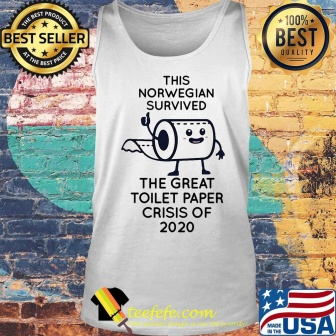Can you describe the main features of this image for me? The image showcases a white tank top, humorously designed and hung against a brick wall backdrop. The tank top features a cartoon of a roll of toilet paper, anthropomorphized with arms and legs. The toilet paper roll appears to be in a triumphant pose, celebrating survival. Emblazoned across the tank top is the text "This Norwegian survived the great toilet paper crisis of 2020", a humorous reference to the toilet paper shortages during the early days of the COVID-19 pandemic.

The tank top is the central object in the image, with its white color contrasting against the rustic brick wall. On the right side of the image, an American flag is displayed, adding a patriotic touch to the scene. The image also includes two badges, one on the top left corner labeled "best seller" and another on the top right corner boasting "100% best quality", indicating the popularity and quality of the product. The badges are small but noticeable, adding credibility to the product. The overall layout of the image suggests it's an online product listing or advertisement. 